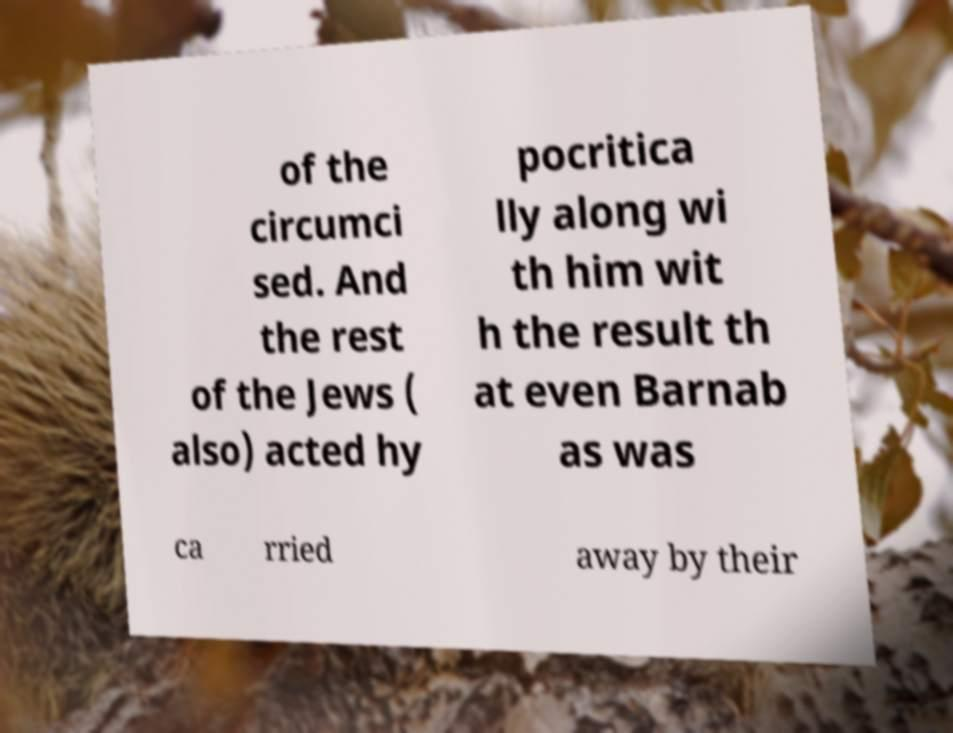Could you assist in decoding the text presented in this image and type it out clearly? of the circumci sed. And the rest of the Jews ( also) acted hy pocritica lly along wi th him wit h the result th at even Barnab as was ca rried away by their 